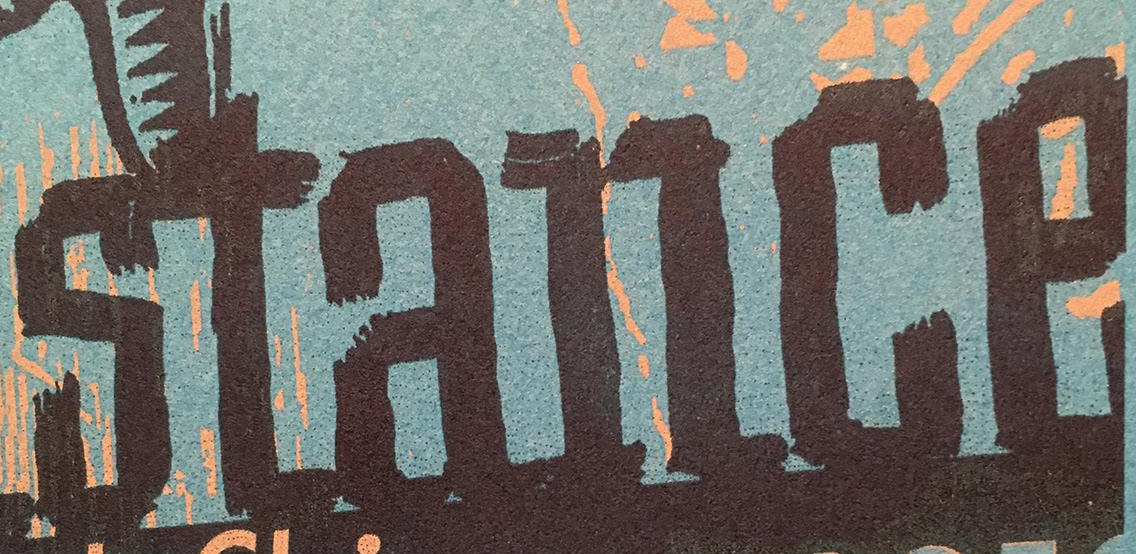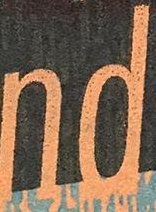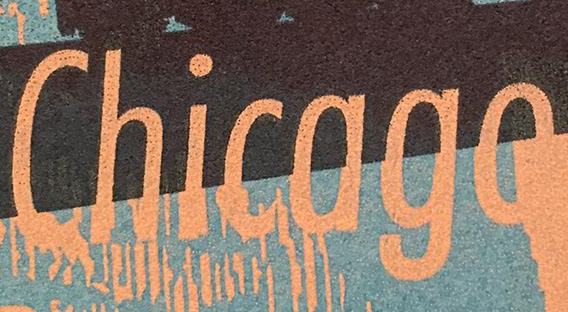What text is displayed in these images sequentially, separated by a semicolon? stance; nd; Chicago 